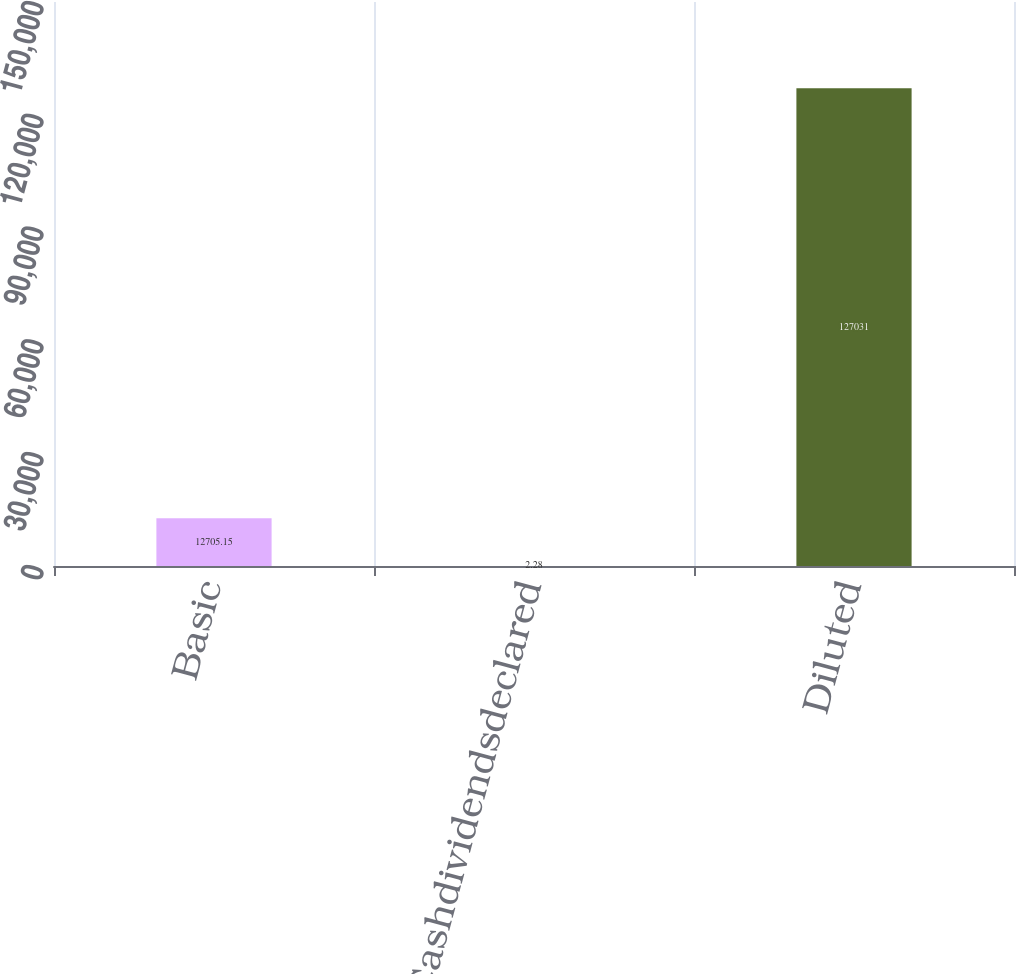Convert chart to OTSL. <chart><loc_0><loc_0><loc_500><loc_500><bar_chart><fcel>Basic<fcel>Cashdividendsdeclared<fcel>Diluted<nl><fcel>12705.1<fcel>2.28<fcel>127031<nl></chart> 